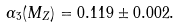<formula> <loc_0><loc_0><loc_500><loc_500>\alpha _ { 3 } ( M _ { Z } ) = 0 . 1 1 9 \pm 0 . 0 0 2 .</formula> 